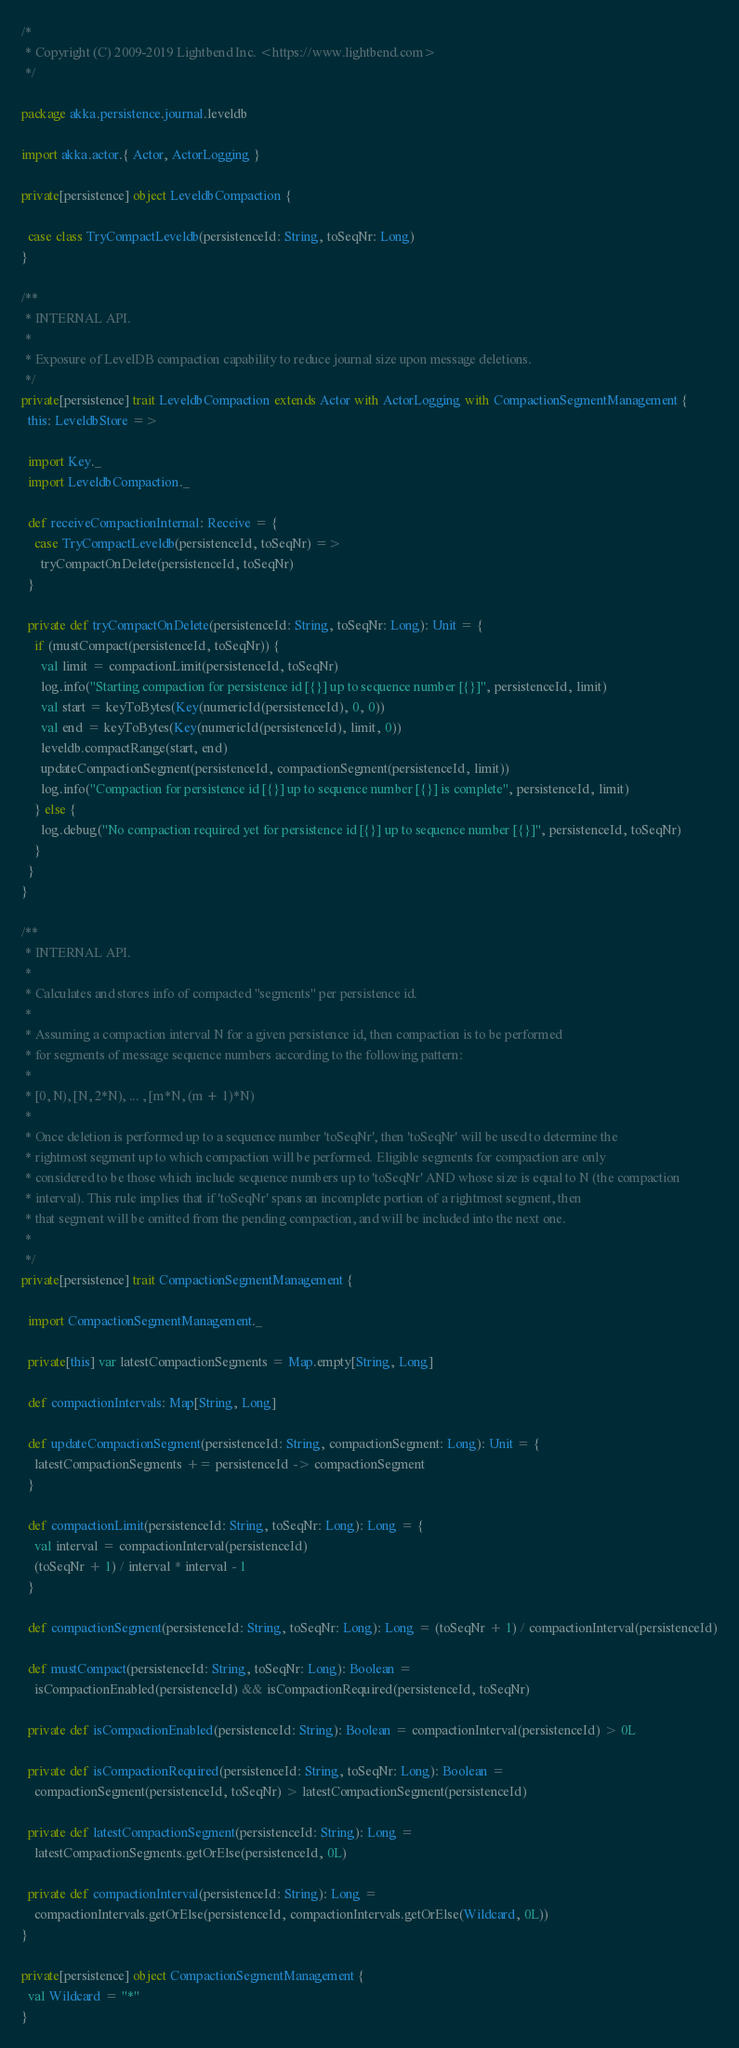Convert code to text. <code><loc_0><loc_0><loc_500><loc_500><_Scala_>/*
 * Copyright (C) 2009-2019 Lightbend Inc. <https://www.lightbend.com>
 */

package akka.persistence.journal.leveldb

import akka.actor.{ Actor, ActorLogging }

private[persistence] object LeveldbCompaction {

  case class TryCompactLeveldb(persistenceId: String, toSeqNr: Long)
}

/**
 * INTERNAL API.
 *
 * Exposure of LevelDB compaction capability to reduce journal size upon message deletions.
 */
private[persistence] trait LeveldbCompaction extends Actor with ActorLogging with CompactionSegmentManagement {
  this: LeveldbStore =>

  import Key._
  import LeveldbCompaction._

  def receiveCompactionInternal: Receive = {
    case TryCompactLeveldb(persistenceId, toSeqNr) =>
      tryCompactOnDelete(persistenceId, toSeqNr)
  }

  private def tryCompactOnDelete(persistenceId: String, toSeqNr: Long): Unit = {
    if (mustCompact(persistenceId, toSeqNr)) {
      val limit = compactionLimit(persistenceId, toSeqNr)
      log.info("Starting compaction for persistence id [{}] up to sequence number [{}]", persistenceId, limit)
      val start = keyToBytes(Key(numericId(persistenceId), 0, 0))
      val end = keyToBytes(Key(numericId(persistenceId), limit, 0))
      leveldb.compactRange(start, end)
      updateCompactionSegment(persistenceId, compactionSegment(persistenceId, limit))
      log.info("Compaction for persistence id [{}] up to sequence number [{}] is complete", persistenceId, limit)
    } else {
      log.debug("No compaction required yet for persistence id [{}] up to sequence number [{}]", persistenceId, toSeqNr)
    }
  }
}

/**
 * INTERNAL API.
 *
 * Calculates and stores info of compacted "segments" per persistence id.
 *
 * Assuming a compaction interval N for a given persistence id, then compaction is to be performed
 * for segments of message sequence numbers according to the following pattern:
 *
 * [0, N), [N, 2*N), ... , [m*N, (m + 1)*N)
 *
 * Once deletion is performed up to a sequence number 'toSeqNr', then 'toSeqNr' will be used to determine the
 * rightmost segment up to which compaction will be performed. Eligible segments for compaction are only
 * considered to be those which include sequence numbers up to 'toSeqNr' AND whose size is equal to N (the compaction
 * interval). This rule implies that if 'toSeqNr' spans an incomplete portion of a rightmost segment, then
 * that segment will be omitted from the pending compaction, and will be included into the next one.
 *
 */
private[persistence] trait CompactionSegmentManagement {

  import CompactionSegmentManagement._

  private[this] var latestCompactionSegments = Map.empty[String, Long]

  def compactionIntervals: Map[String, Long]

  def updateCompactionSegment(persistenceId: String, compactionSegment: Long): Unit = {
    latestCompactionSegments += persistenceId -> compactionSegment
  }

  def compactionLimit(persistenceId: String, toSeqNr: Long): Long = {
    val interval = compactionInterval(persistenceId)
    (toSeqNr + 1) / interval * interval - 1
  }

  def compactionSegment(persistenceId: String, toSeqNr: Long): Long = (toSeqNr + 1) / compactionInterval(persistenceId)

  def mustCompact(persistenceId: String, toSeqNr: Long): Boolean =
    isCompactionEnabled(persistenceId) && isCompactionRequired(persistenceId, toSeqNr)

  private def isCompactionEnabled(persistenceId: String): Boolean = compactionInterval(persistenceId) > 0L

  private def isCompactionRequired(persistenceId: String, toSeqNr: Long): Boolean =
    compactionSegment(persistenceId, toSeqNr) > latestCompactionSegment(persistenceId)

  private def latestCompactionSegment(persistenceId: String): Long =
    latestCompactionSegments.getOrElse(persistenceId, 0L)

  private def compactionInterval(persistenceId: String): Long =
    compactionIntervals.getOrElse(persistenceId, compactionIntervals.getOrElse(Wildcard, 0L))
}

private[persistence] object CompactionSegmentManagement {
  val Wildcard = "*"
}
</code> 